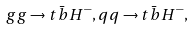Convert formula to latex. <formula><loc_0><loc_0><loc_500><loc_500>g g \rightarrow t \bar { b } H ^ { - } , q q \rightarrow t \bar { b } H ^ { - } ,</formula> 